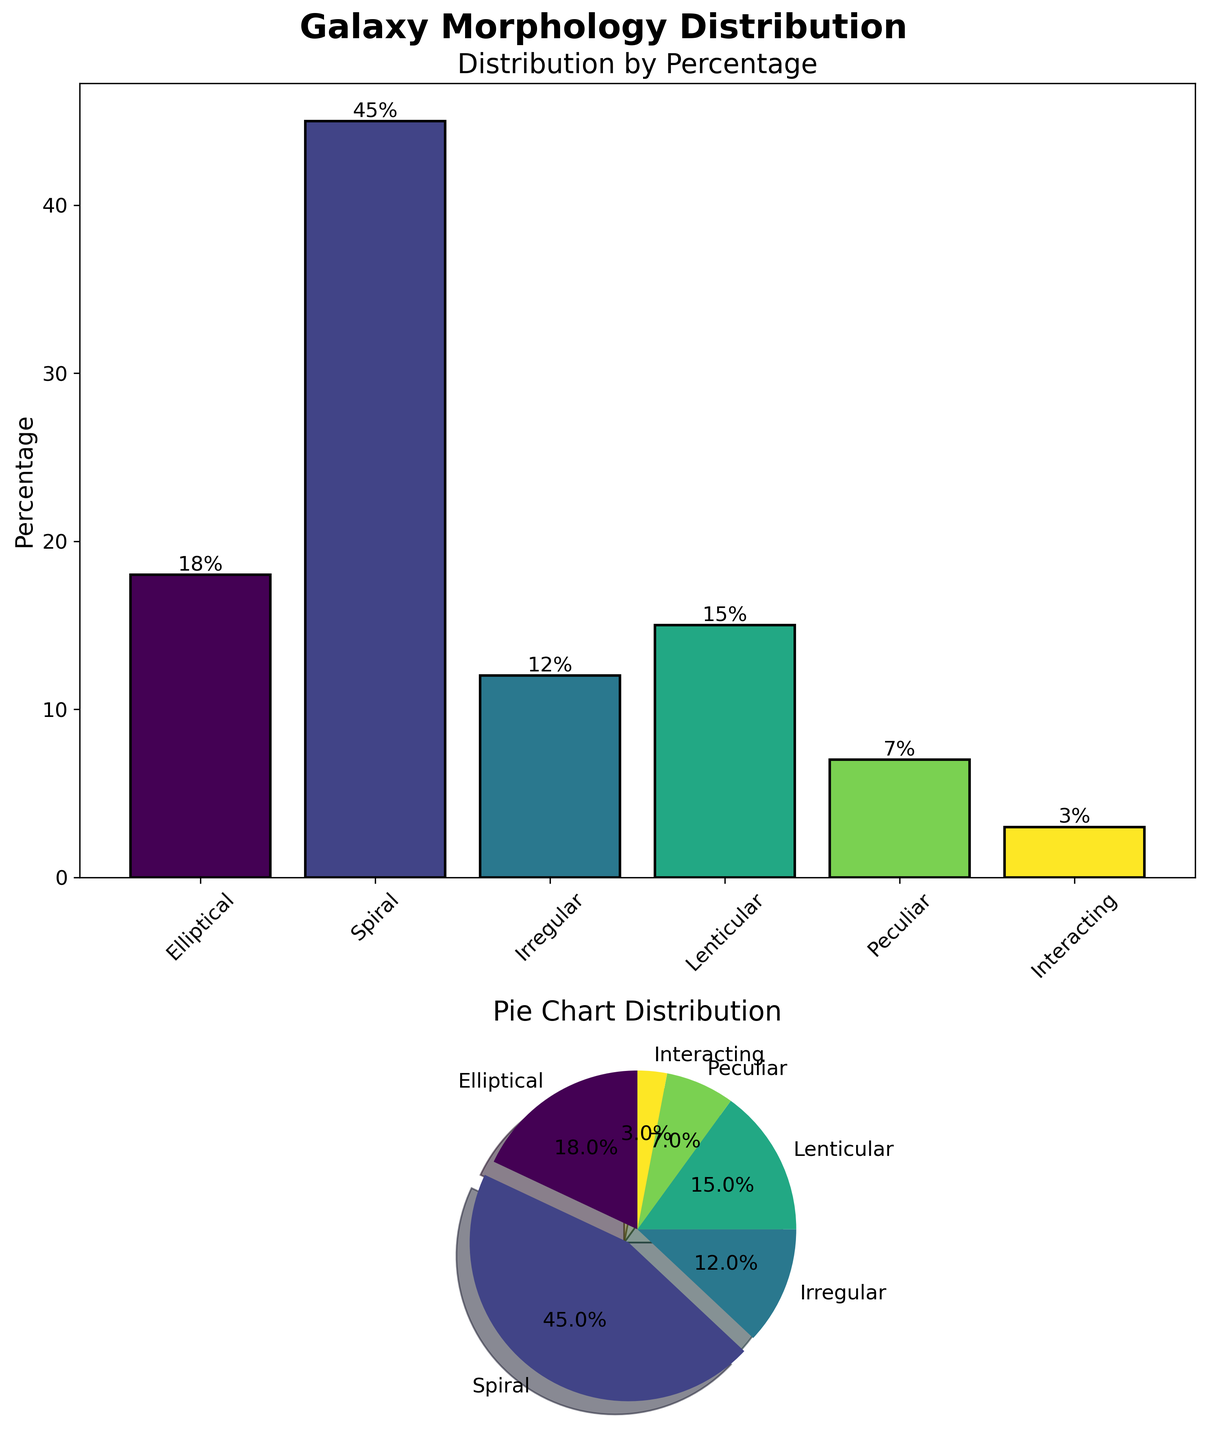What's the title of the figure? The title is placed at the top center of the figure. It reads "Galaxy Morphology Distribution."
Answer: Galaxy Morphology Distribution How many different galaxy morphologies are displayed in the figure? By counting the distinct labels on the x-axis of the bar plot and the labels in the pie chart, we can see there are six different categories.
Answer: Six Which galaxy morphology has the highest percentage? In both the bar plot and pie chart, the 'Spiral' category has the tallest bar and the largest pie section respectively.
Answer: Spiral What's the total percentage of Elliptical and Lenticular galaxies? From the bar plot or the pie chart, Elliptical has 18% and Lenticular has 15%. Adding them together gives 18% + 15% = 33%.
Answer: 33% Which galaxy morphology has the smallest percentage? The smallest section in both the bar plot and pie chart corresponds to the 'Interacting' category with 3%.
Answer: Interacting What’s the difference in percentage between Spiral and Irregular galaxies? From the bar plot or pie chart, Spiral has 45% and Irregular has 12%. The difference is 45% - 12% = 33%.
Answer: 33% Which galaxy morphology categories have a percentage greater than 10%? From the bar plot and pie chart, Elliptical (18%), Spiral (45%), Irregular (12%), and Lenticular (15%) all are greater than 10%.
Answer: Elliptical, Spiral, Irregular, Lenticular What is the combined percentage of Peculiar and Interacting galaxies? In both the bar plot and the pie chart, Peculiar has 7% and Interacting has 3%. Adding them together gives 7% + 3% = 10%.
Answer: 10% What action was taken in the pie chart to highlight a specific category, and which category is it? The pie chart shows a noticeable exploded section which highlights the largest category, 'Spiral'.
Answer: Spiral 